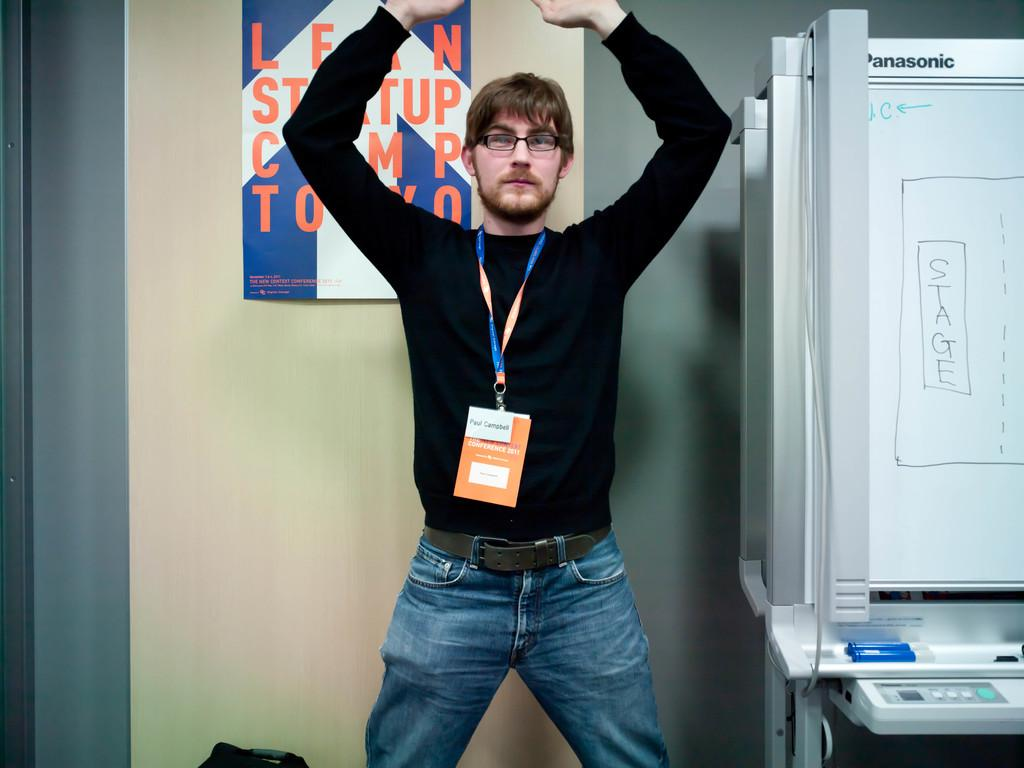<image>
Share a concise interpretation of the image provided. A man in a black shirt that is wearing a lanyard for a 2011 conference. 